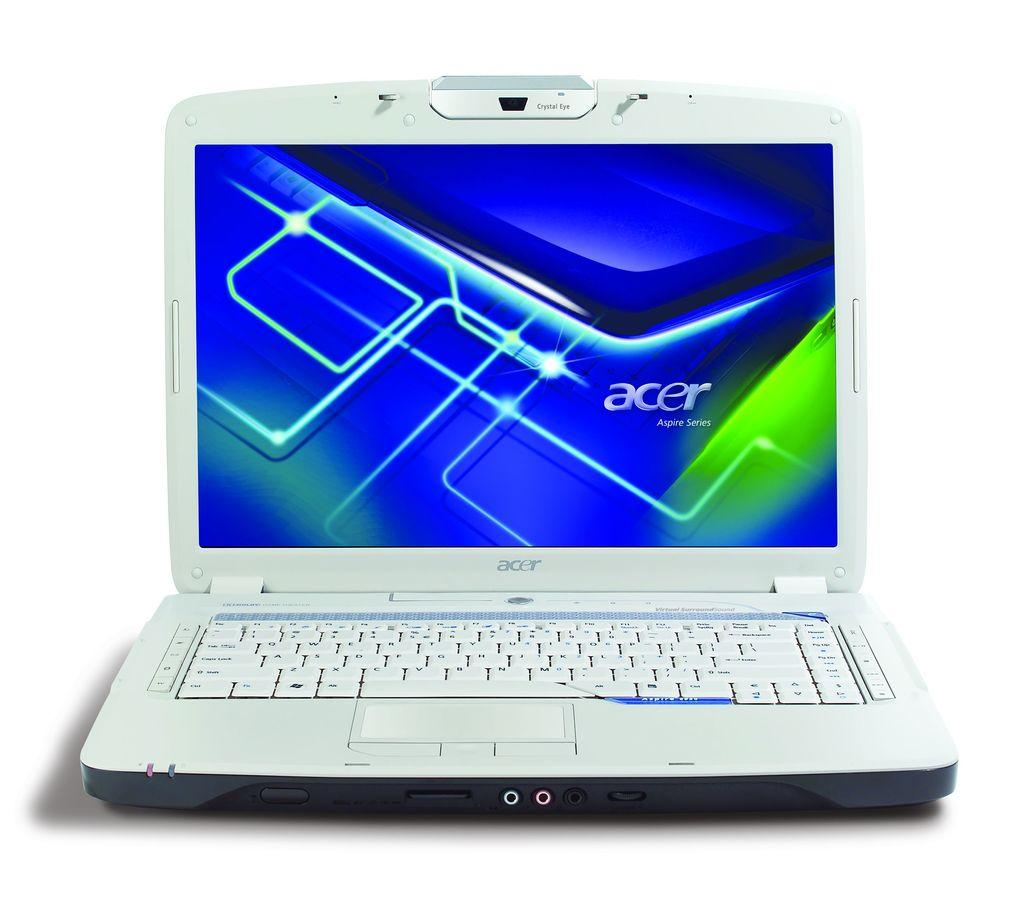Provide a one-sentence caption for the provided image. A computer shows the brand Acer on the screen. 